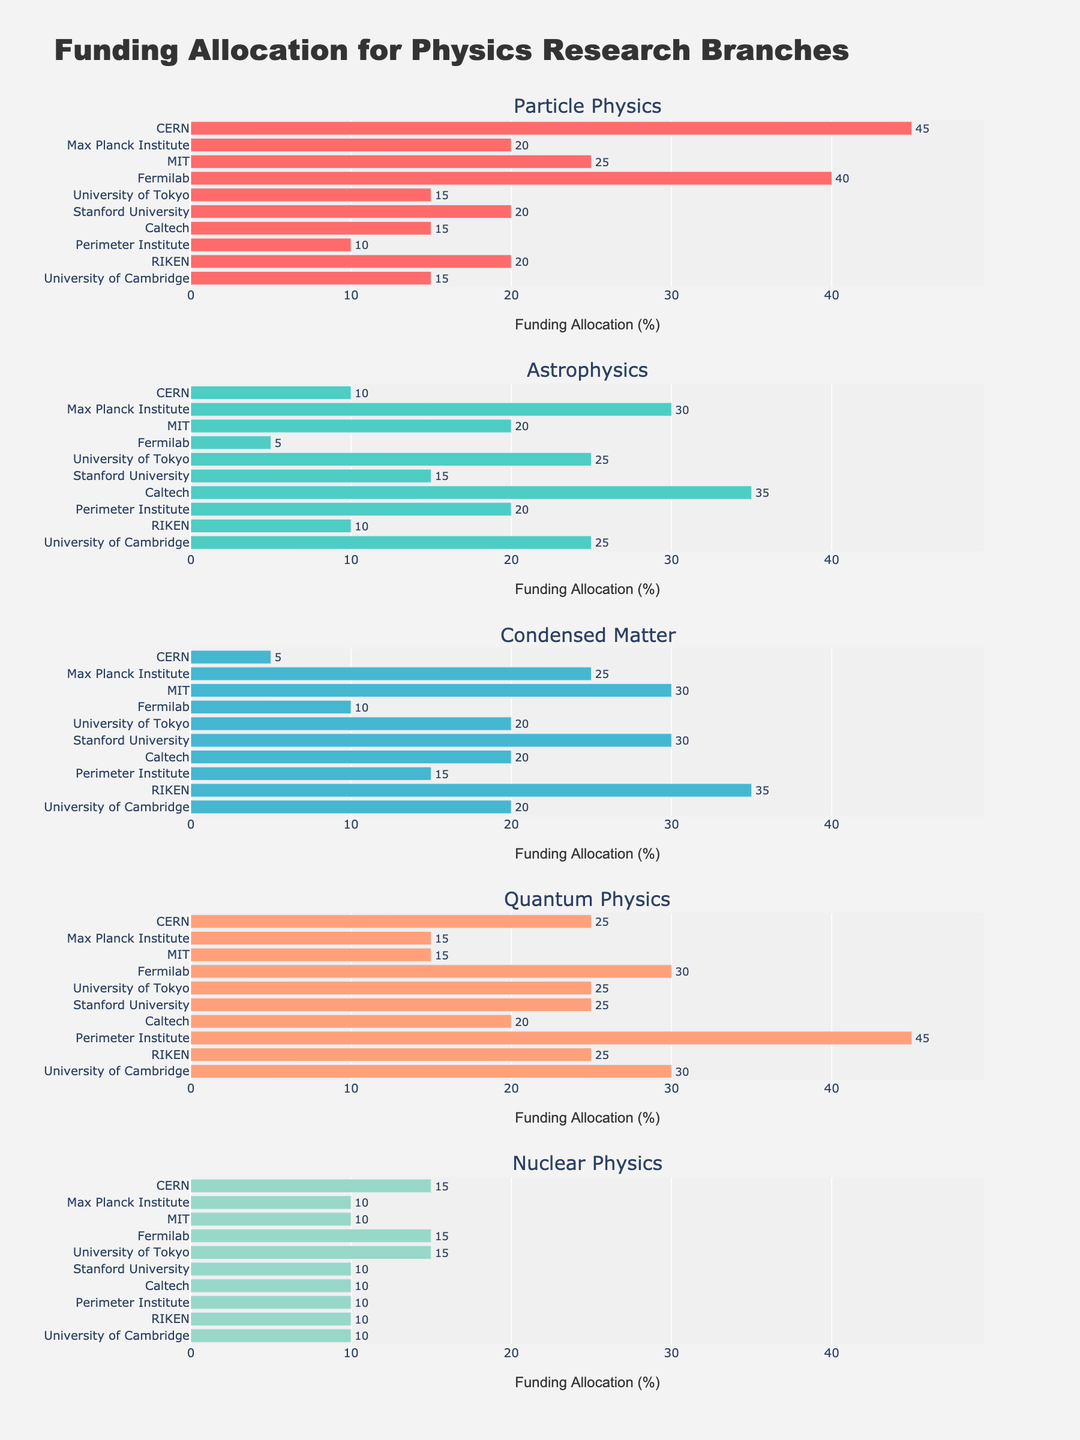What's the institution with the highest funding allocation for Particle Physics? The bar corresponding to Particle Physics shows the highest value for CERN.
Answer: CERN How much funding does MIT allocate to Condensed Matter research? The bar for Condensed Matter research shows a value of 30 for MIT.
Answer: 30 Which institution allocates the most to Quantum Physics? By examining the Quantum Physics sub-plot, the Perimeter Institute has the highest value of 45.
Answer: Perimeter Institute Compare the funding allocation for Astrophysics between Caltech and Max Planck Institute. Caltech allocates 35, while Max Planck Institute allocates 30 for Astrophysics.
Answer: Caltech allocates more Which institution allocates the least funding to Nuclear Physics? The Nuclear Physics sub-plot shows that Max Planck Institute, MIT, Caltech, Perimeter Institute, RIKEN, and University of Cambridge all allocate 10, which is the lowest.
Answer: Max Planck Institute, MIT, Caltech, Perimeter Institute, RIKEN, University of Cambridge How much more funding does Fermilab allocate to Particle Physics compared to University of Tokyo? Fermilab allocates 40, and University of Tokyo allocates 15. The difference is 40 - 15.
Answer: 25 What is the average funding allocation for Condensed Matter research across all institutions? The values for Condensed Matter research are 5, 25, 30, 10, 20, 30, 20, 15, 35, and 20. Sum them to get 210, and divide by 10.
Answer: 21 Is the funding allocation for Quantum Physics in Stanford University higher or lower than in RIKEN? Stanford University allocates 25, while RIKEN allocates 25 for Quantum Physics. Both are equal.
Answer: Equal How does the funding for Particle Physics compare to Nuclear Physics at CERN? CERN allocates 45 to Particle Physics and 15 to Nuclear Physics. Particle Physics has 30 more.
Answer: 30 more Which research branch gets the second highest funding allocation at Max Planck Institute? The highest is Astrophysics (30) and the second highest is Condensed Matter (25).
Answer: Condensed Matter 